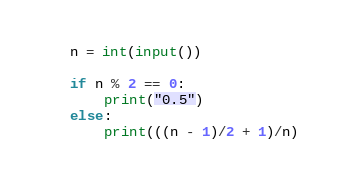<code> <loc_0><loc_0><loc_500><loc_500><_Python_>n = int(input())

if n % 2 == 0:
    print("0.5")
else:
    print(((n - 1)/2 + 1)/n)</code> 